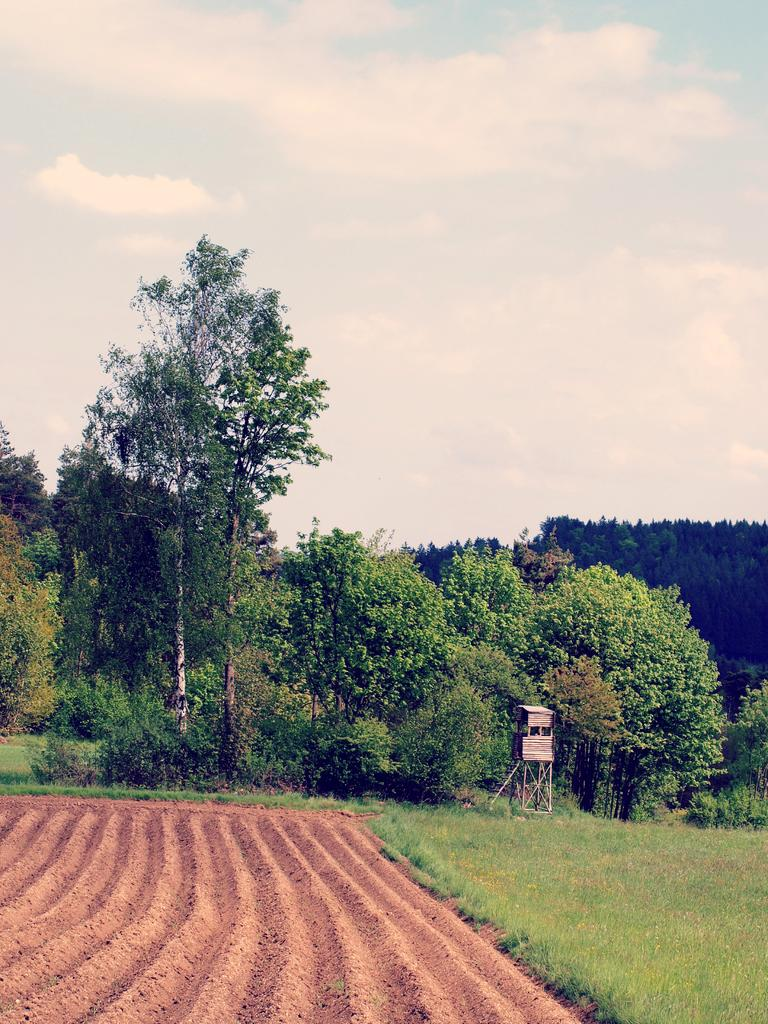What type of vegetation is on the right side of the image? There is grass on the right side of the image. What type of terrain is on the left side of the image? There is sand on the left side of the image. What other natural elements can be seen in the image? There are trees in the image. What is visible at the top of the image? The sky is visible at the top of the image. What language is spoken by the sack in the image? There is no sack present in the image, and therefore no language can be attributed to it. Can you tell me how the skate is used in the image? There is no skate present in the image, so it cannot be used or depicted in any way. 